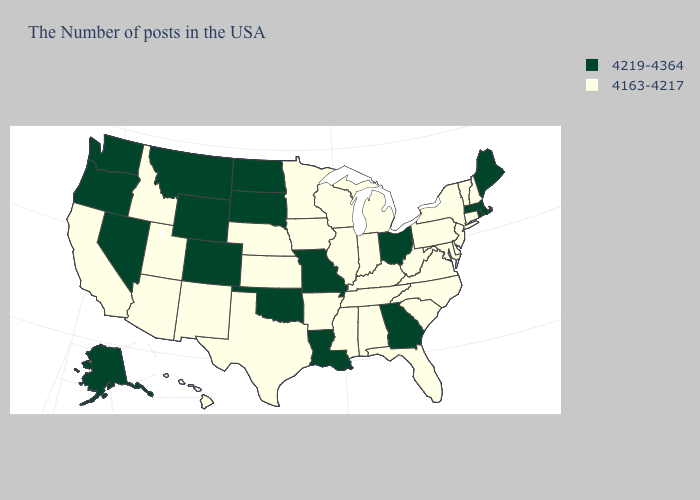What is the lowest value in the USA?
Short answer required. 4163-4217. Which states have the lowest value in the Northeast?
Keep it brief. New Hampshire, Vermont, Connecticut, New York, New Jersey, Pennsylvania. What is the value of Louisiana?
Quick response, please. 4219-4364. What is the value of South Dakota?
Short answer required. 4219-4364. What is the value of West Virginia?
Answer briefly. 4163-4217. Which states have the highest value in the USA?
Write a very short answer. Maine, Massachusetts, Rhode Island, Ohio, Georgia, Louisiana, Missouri, Oklahoma, South Dakota, North Dakota, Wyoming, Colorado, Montana, Nevada, Washington, Oregon, Alaska. Name the states that have a value in the range 4219-4364?
Short answer required. Maine, Massachusetts, Rhode Island, Ohio, Georgia, Louisiana, Missouri, Oklahoma, South Dakota, North Dakota, Wyoming, Colorado, Montana, Nevada, Washington, Oregon, Alaska. What is the highest value in states that border Utah?
Give a very brief answer. 4219-4364. Does Oregon have the lowest value in the USA?
Give a very brief answer. No. Does New Jersey have the highest value in the Northeast?
Be succinct. No. What is the value of North Carolina?
Concise answer only. 4163-4217. How many symbols are there in the legend?
Keep it brief. 2. What is the value of Rhode Island?
Give a very brief answer. 4219-4364. Among the states that border New Mexico , which have the highest value?
Keep it brief. Oklahoma, Colorado. Among the states that border Colorado , does Wyoming have the lowest value?
Give a very brief answer. No. 